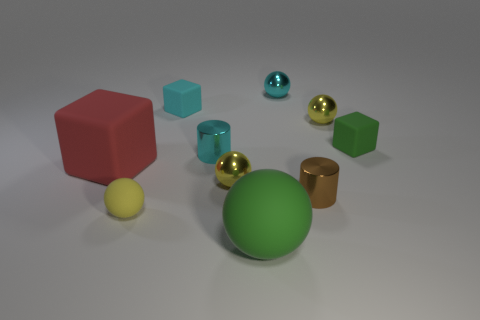Can you describe the lighting in the scene? The lighting in the image provides a soft, diffused illumination, creating gentle shadows on the floor beneath each object. There seems to be a primary light source that casts light from above and to the right, which is evident from the highlights and shadows direction. 